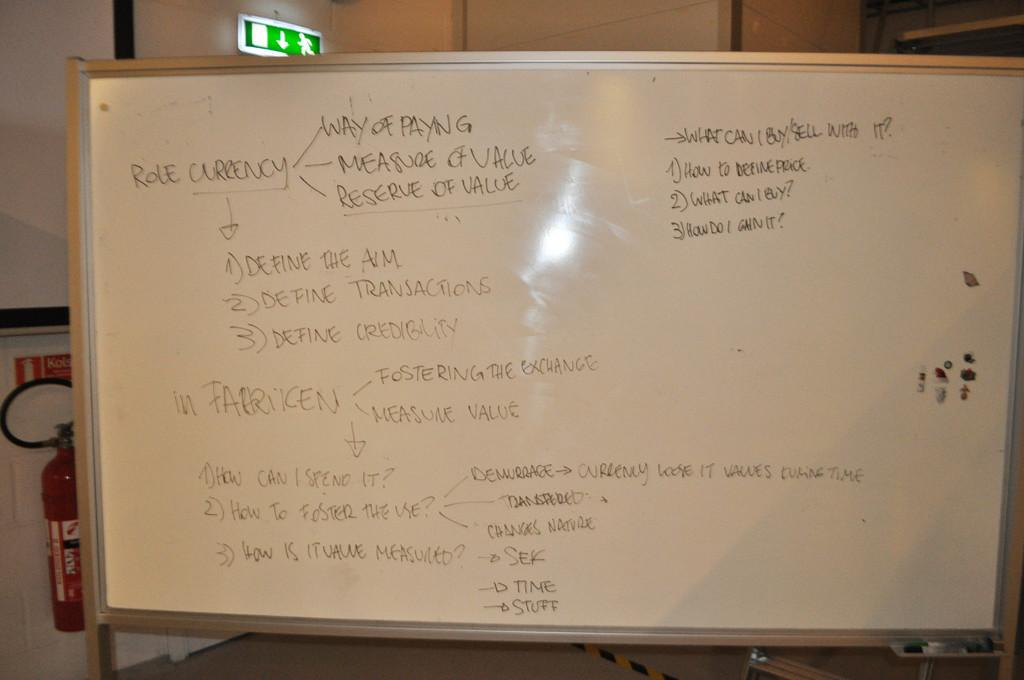<image>
Relay a brief, clear account of the picture shown. A flowchart written on a whiteboard tells of Role Currency and how to define things. 